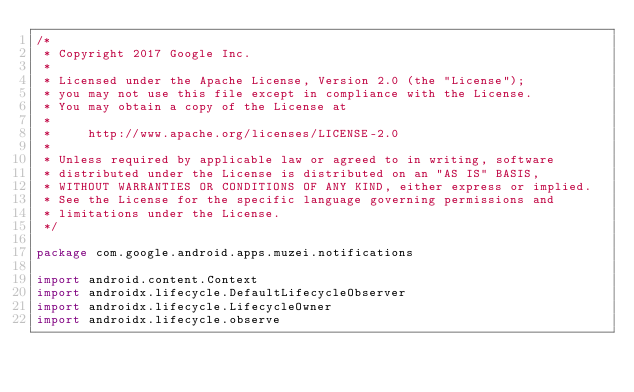<code> <loc_0><loc_0><loc_500><loc_500><_Kotlin_>/*
 * Copyright 2017 Google Inc.
 *
 * Licensed under the Apache License, Version 2.0 (the "License");
 * you may not use this file except in compliance with the License.
 * You may obtain a copy of the License at
 *
 *     http://www.apache.org/licenses/LICENSE-2.0
 *
 * Unless required by applicable law or agreed to in writing, software
 * distributed under the License is distributed on an "AS IS" BASIS,
 * WITHOUT WARRANTIES OR CONDITIONS OF ANY KIND, either express or implied.
 * See the License for the specific language governing permissions and
 * limitations under the License.
 */

package com.google.android.apps.muzei.notifications

import android.content.Context
import androidx.lifecycle.DefaultLifecycleObserver
import androidx.lifecycle.LifecycleOwner
import androidx.lifecycle.observe</code> 